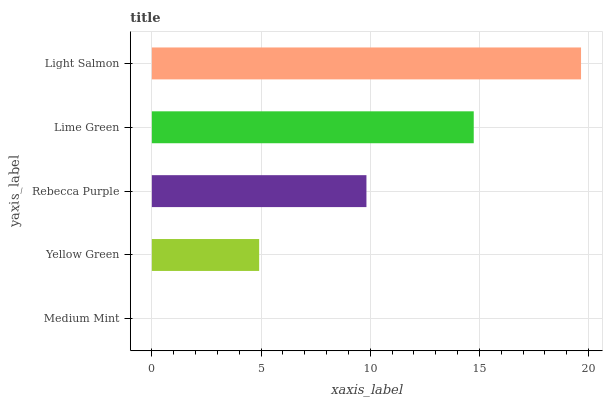Is Medium Mint the minimum?
Answer yes or no. Yes. Is Light Salmon the maximum?
Answer yes or no. Yes. Is Yellow Green the minimum?
Answer yes or no. No. Is Yellow Green the maximum?
Answer yes or no. No. Is Yellow Green greater than Medium Mint?
Answer yes or no. Yes. Is Medium Mint less than Yellow Green?
Answer yes or no. Yes. Is Medium Mint greater than Yellow Green?
Answer yes or no. No. Is Yellow Green less than Medium Mint?
Answer yes or no. No. Is Rebecca Purple the high median?
Answer yes or no. Yes. Is Rebecca Purple the low median?
Answer yes or no. Yes. Is Lime Green the high median?
Answer yes or no. No. Is Light Salmon the low median?
Answer yes or no. No. 